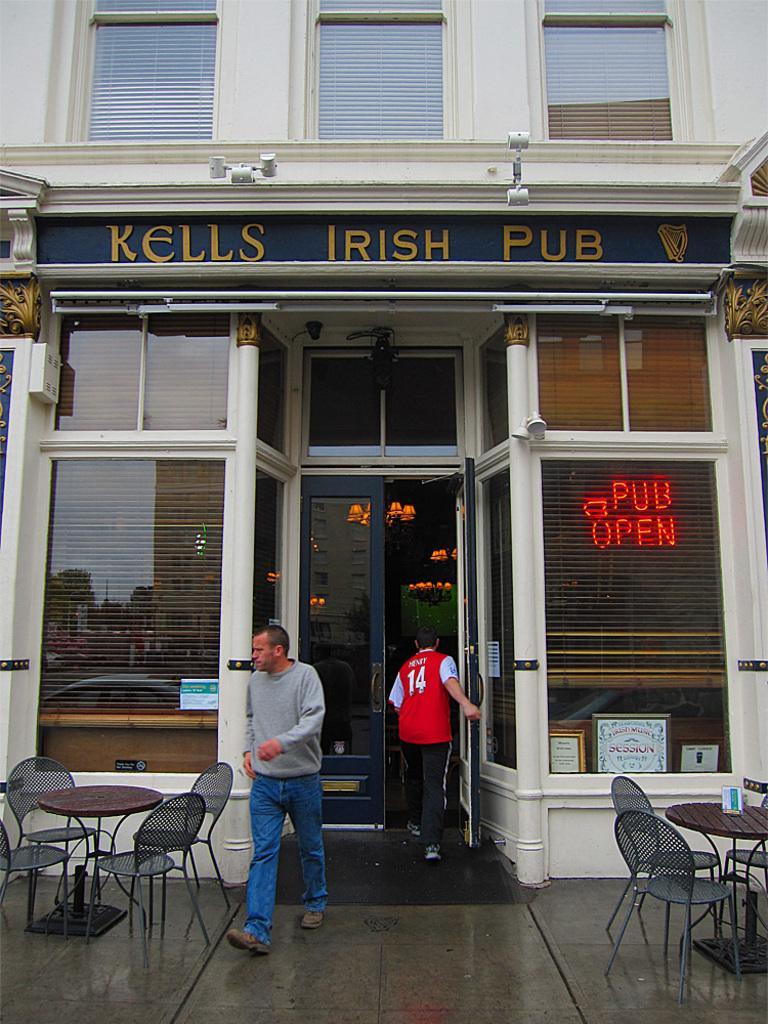What type of furniture can be seen in the image? There are chairs and a table in the image. What are the persons in the background of the image doing? The persons in the background of the image are walking. What is visible in the background of the image? There is a store visible in the background of the image. What feature allows for a view of the outside in the image? There is a window in the image. What color is the eye of the person sitting on the chair in the image? There is no eye visible in the image; it is not possible to determine the color of someone's eye from the provided facts. 